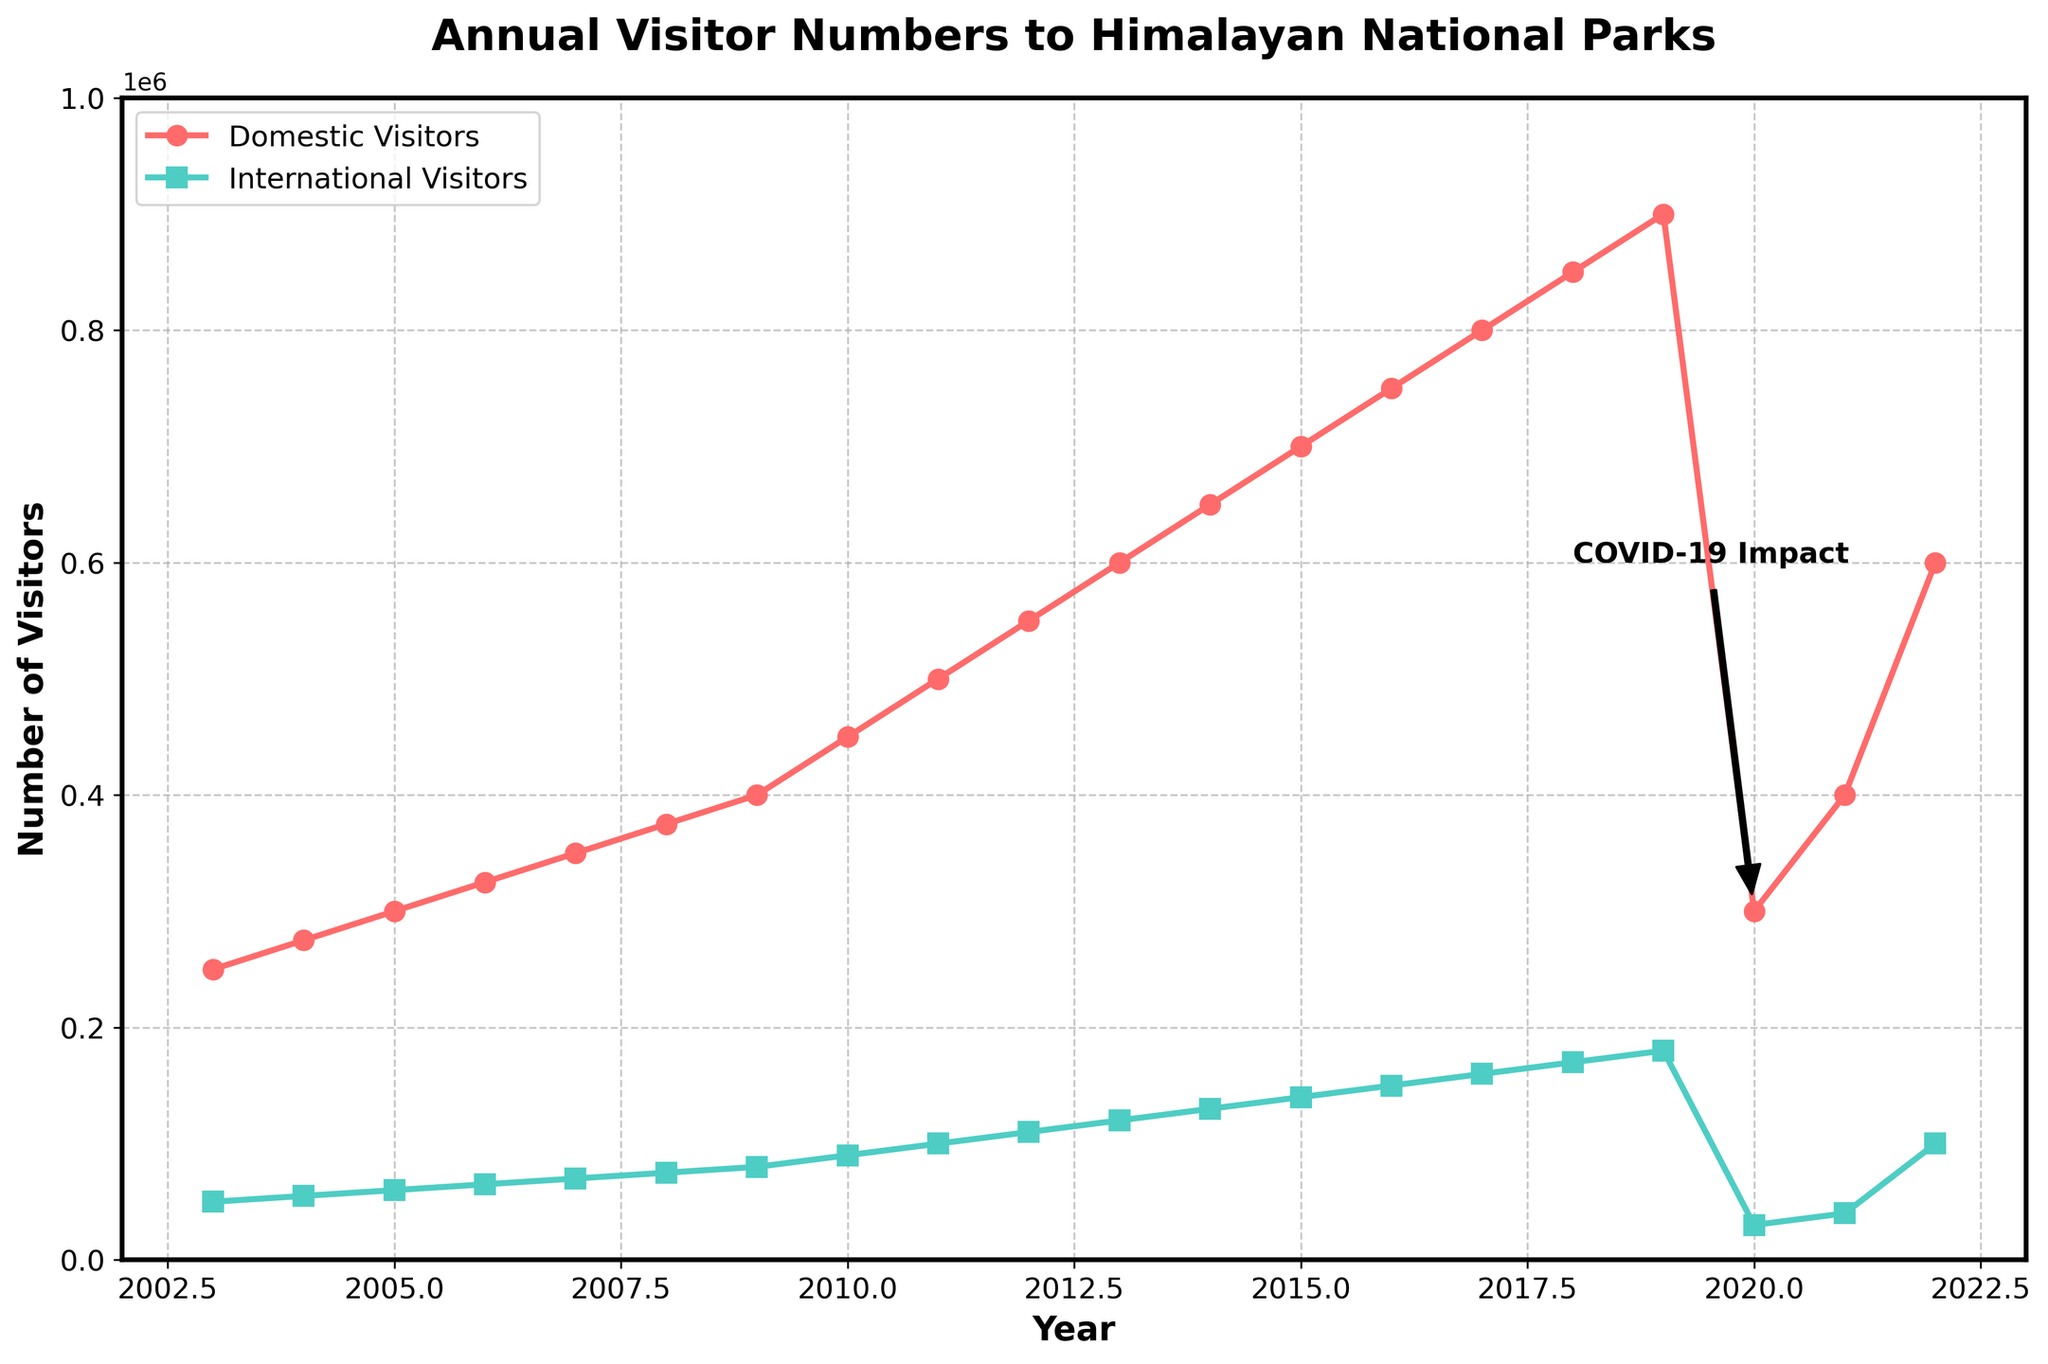What is the total number of visitors in 2012? To find the total number of visitors in 2012, sum the Domestic Visitors and International Visitors for that year: 550,000 (Domestic) + 110,000 (International) = 660,000
Answer: 660,000 In which year did international visitors first exceed 100,000? Look along the plot line for International Visitors and identify the first year where the y-value surpasses 100,000. This occurs in 2011 when International Visitors reach 100,000.
Answer: 2011 How many more domestic visitors were there compared to international visitors in 2006? Find the number of Domestic Visitors and International Visitors in 2006, and calculate the difference: 325,000 (Domestic) - 65,000 (International) = 260,000
Answer: 260,000 In which year did both domestic and international visitors experience a noticeable drop? Identify the year where there's a significant drop in both lines. This is in 2020, marking the impact of COVID-19.
Answer: 2020 How did the number of domestic visitors change between 2019 and 2020? Subtract the number of Domestic Visitors in 2020 from that in 2019: 900,000 (2019) - 300,000 (2020) = 600,000 decrease
Answer: Decreased by 600,000 By what percentage did international visitors decrease from 2019 to 2020? Calculate the percentage decrease: ((180,000 - 30,000) / 180,000) * 100%. This reduction is significant and equals to 83.33%.
Answer: 83.33% How did the annual number of visitors (domestic and international combined) change from 2020 to 2022? Calculate the combined visitors for 2020 and 2022, then find the difference and describe the change: (300,000 + 30,000) in 2020 vs. (600,000 + 100,000) in 2022. 330,000 in 2020 vs. 700,000 in 2022 is an increase of 370,000
Answer: Increased by 370,000 What is the average annual number of domestic visitors from 2003 to 2019? Sum the total number of domestic visitors from 2003 to 2019 and divide by the number of years: (250,000 + 275,000 + ... + 900,000) / 17. The sum is 7,725,000 so the average is 455,882
Answer: 455,882 Compare the growth rate of international visitors from 2003 to 2019 with domestic visitors in the same period Calculate the growth for both segments over the period and compare: International from 50,000 to 180,000, Domestic from 250,000 to 900,000. International growth rate = (180,000 - 50,000) / 50,000 = 260%. Domestic growth = (900,000 - 250,000) / 250,000 = 260%. Both have grown proportionally at the same rate
Answer: Same rate (260%) In which year did the total annual visitors (domestic + international) reach the highest, and what was the number? Add Domestic and International Visitors for each year and identify the highest sum: 900,000 (Domestic) + 180,000 (International) in 2019 totals 1,080,000, which is the highest
Answer: 2019, 1,080,000 